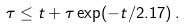<formula> <loc_0><loc_0><loc_500><loc_500>\tau \leq t + \tau \exp ( - t / 2 . 1 7 ) \, .</formula> 